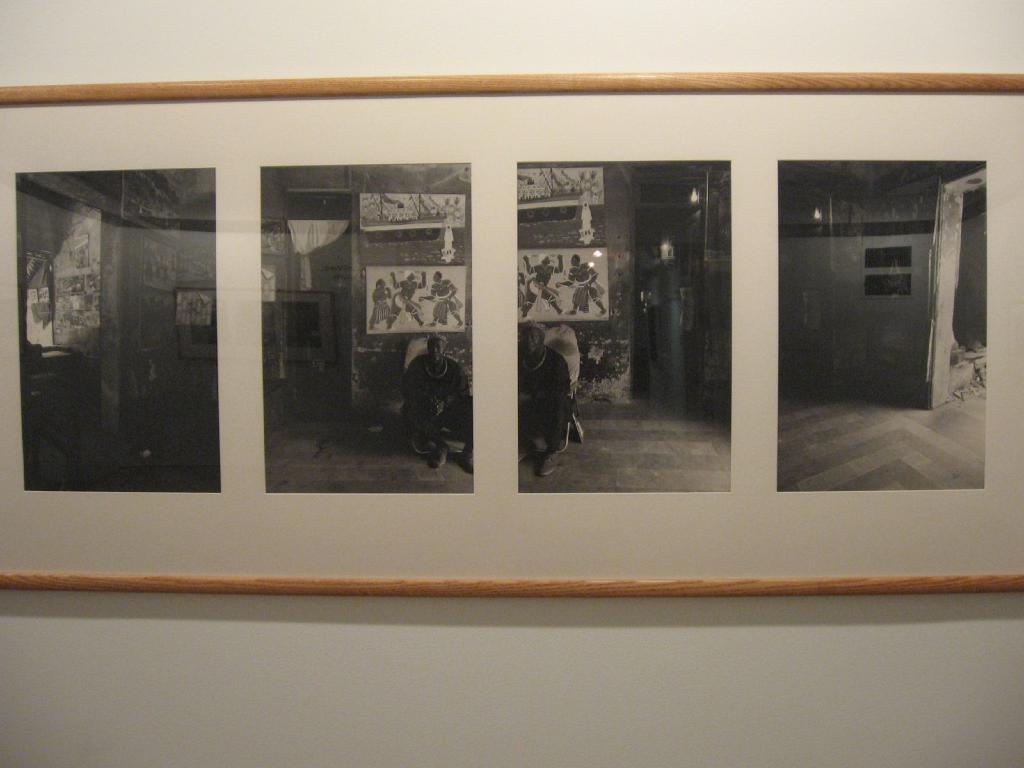What object in the image is used for displaying photos? There is a photo frame in the image. How many photos are displayed in the photo frame? The photo frame contains four photos. Where is the photo frame located in the image? The photo frame is attached to the wall. What type of ice is being prepared in the oven in the image? There is no oven or ice present in the image; it features a photo frame with four photos. What type of feast is being prepared in the image? There is no feast being prepared in the image; it features a photo frame with four photos. 